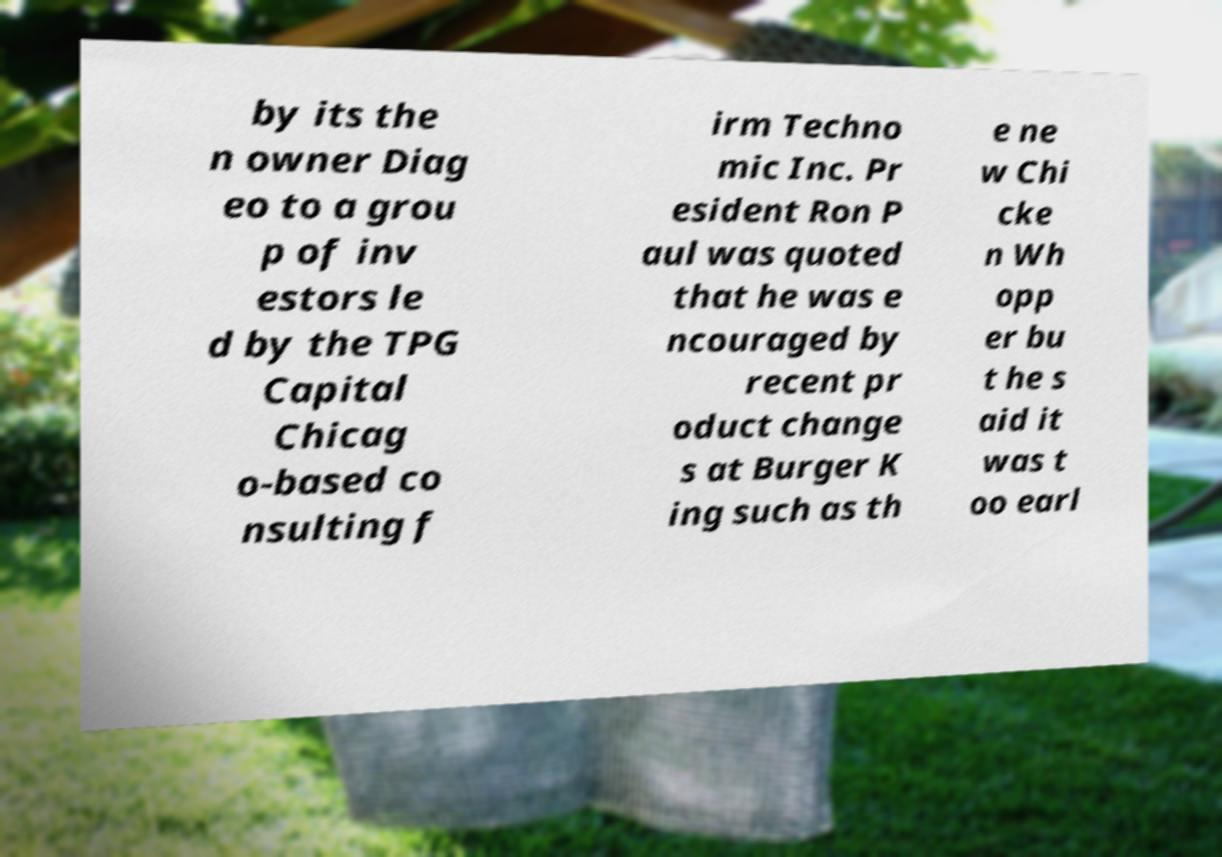What messages or text are displayed in this image? I need them in a readable, typed format. by its the n owner Diag eo to a grou p of inv estors le d by the TPG Capital Chicag o-based co nsulting f irm Techno mic Inc. Pr esident Ron P aul was quoted that he was e ncouraged by recent pr oduct change s at Burger K ing such as th e ne w Chi cke n Wh opp er bu t he s aid it was t oo earl 